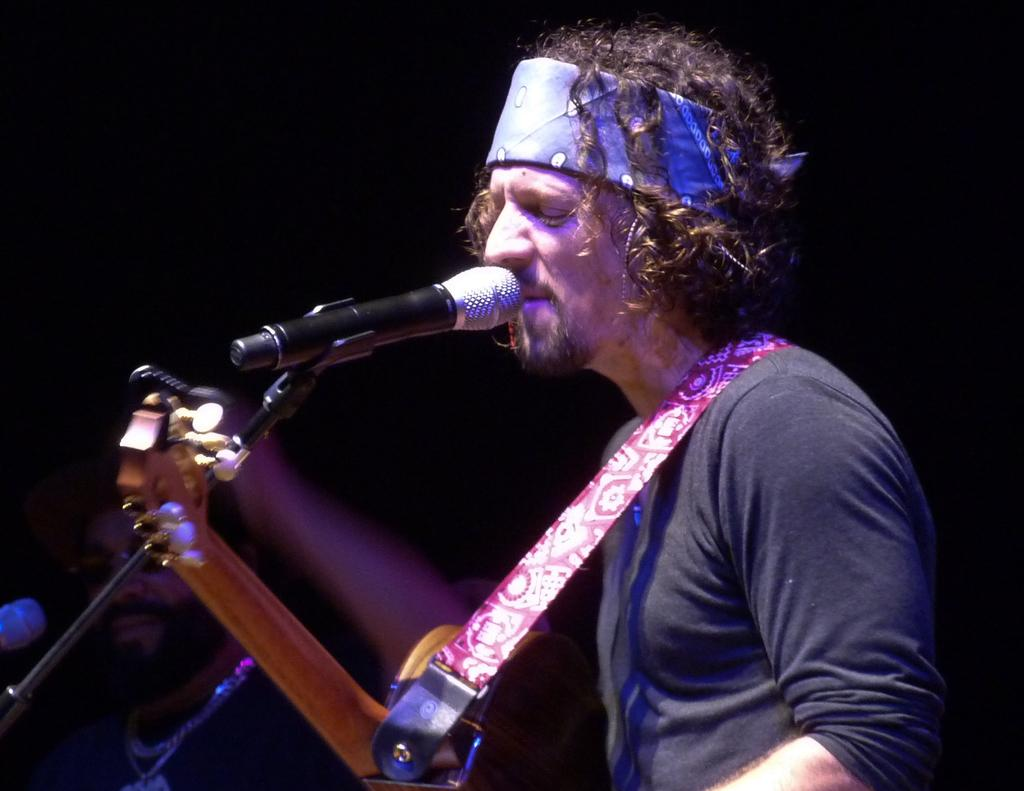What is the main subject of the image? There is a person in the image. What is the person doing in the image? The person is singing in the image. What object is the person using while singing? The person is in front of a microphone in the image. What else is the person holding in the image? The person is holding a musical instrument in the image. What type of secretary can be seen learning at the end of the image? There is no secretary or learning activity present in the image. 